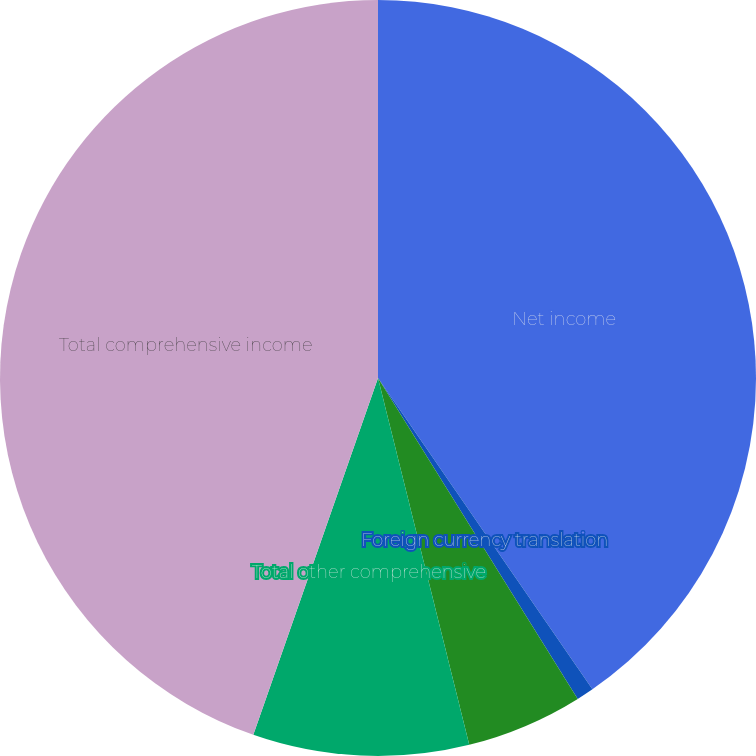Convert chart to OTSL. <chart><loc_0><loc_0><loc_500><loc_500><pie_chart><fcel>Net income<fcel>Foreign currency translation<fcel>Net change in unrecognized<fcel>Total other comprehensive<fcel>Total comprehensive income<nl><fcel>40.4%<fcel>0.74%<fcel>4.98%<fcel>9.23%<fcel>44.65%<nl></chart> 